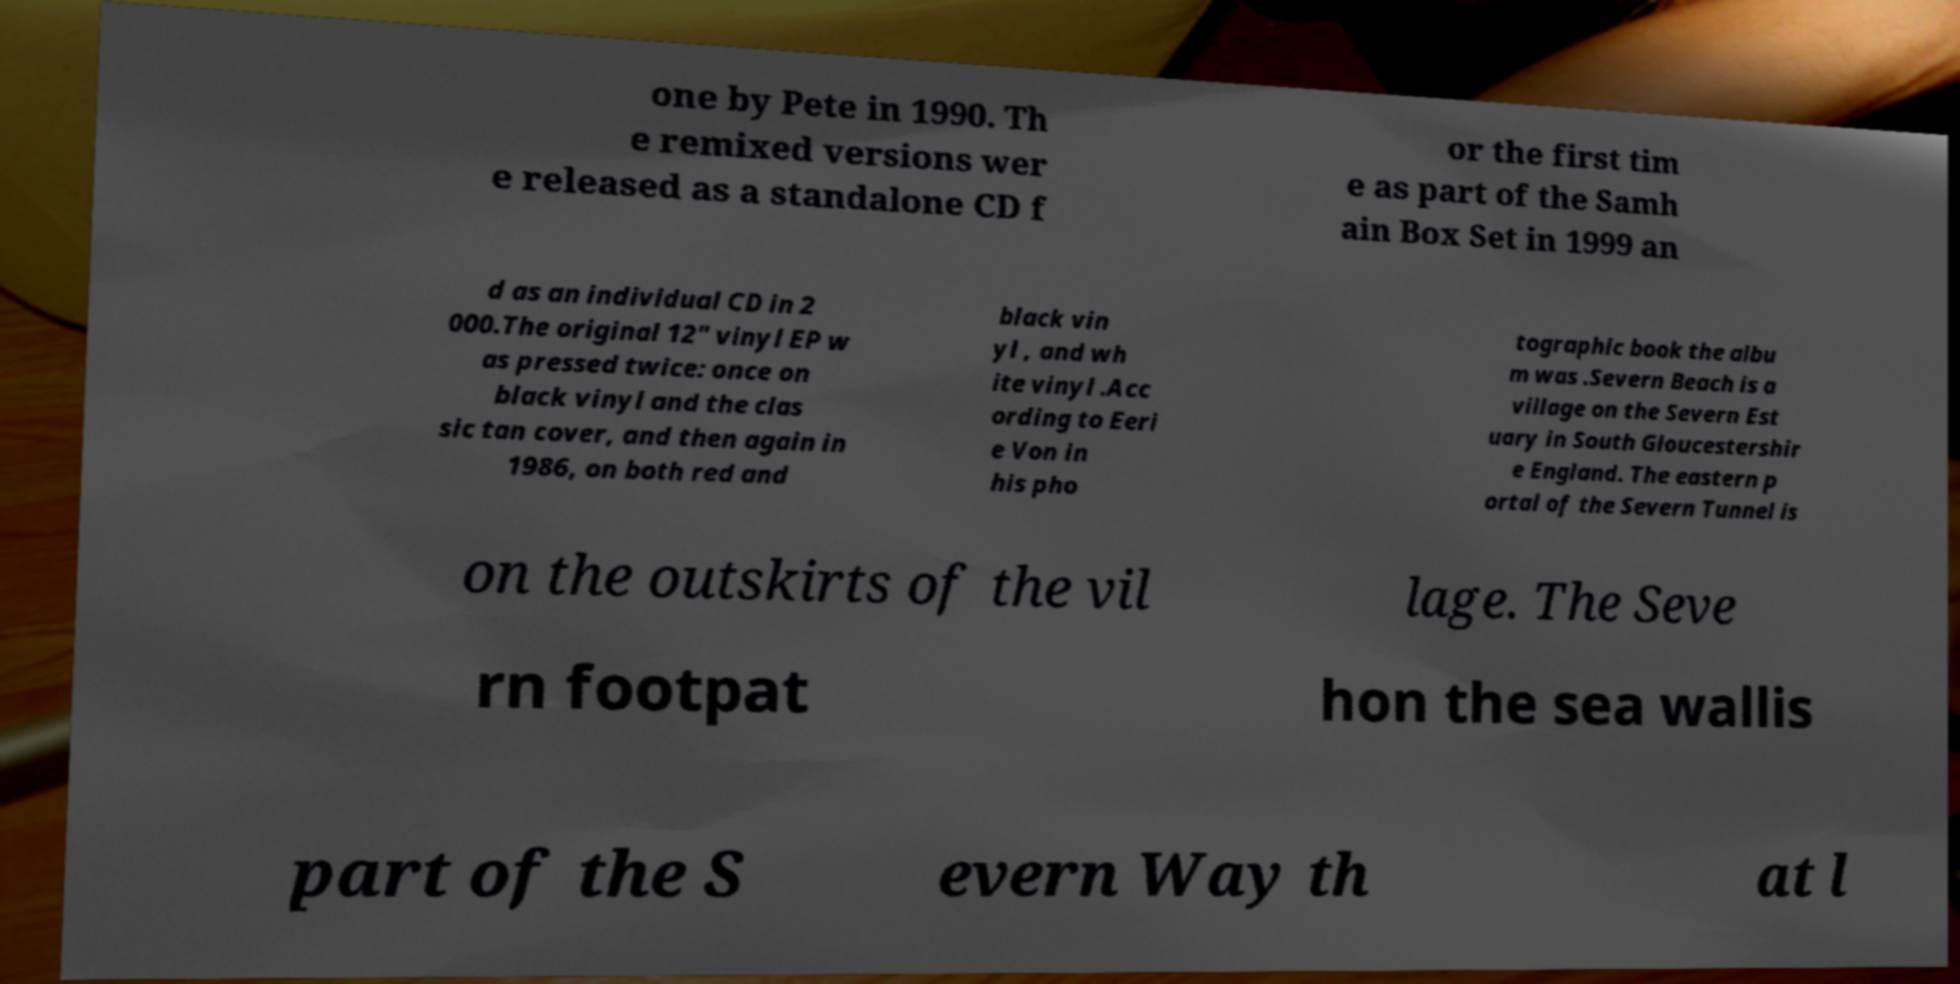Could you assist in decoding the text presented in this image and type it out clearly? one by Pete in 1990. Th e remixed versions wer e released as a standalone CD f or the first tim e as part of the Samh ain Box Set in 1999 an d as an individual CD in 2 000.The original 12" vinyl EP w as pressed twice: once on black vinyl and the clas sic tan cover, and then again in 1986, on both red and black vin yl , and wh ite vinyl .Acc ording to Eeri e Von in his pho tographic book the albu m was .Severn Beach is a village on the Severn Est uary in South Gloucestershir e England. The eastern p ortal of the Severn Tunnel is on the outskirts of the vil lage. The Seve rn footpat hon the sea wallis part of the S evern Way th at l 